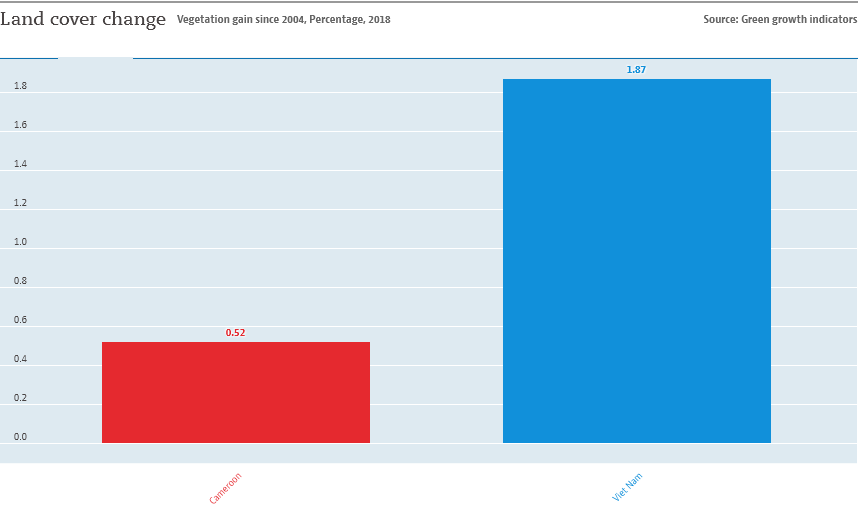Mention a couple of crucial points in this snapshot. Cameroon, represented by the country of red, is the one that stated the sentence. The average value of both bars is 1.195... 